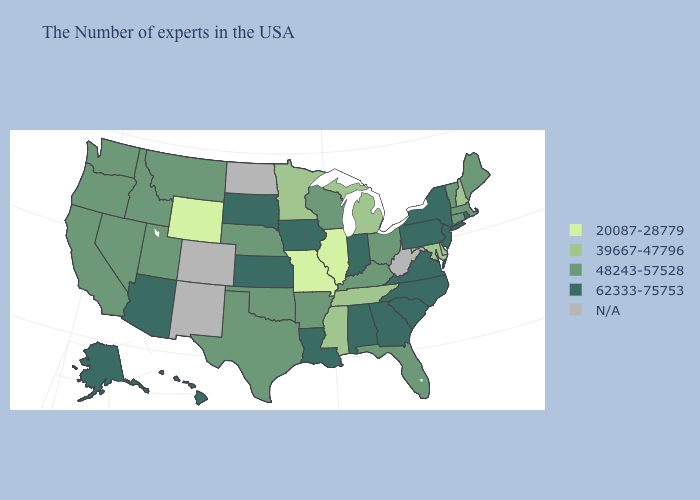Does Alabama have the highest value in the South?
Answer briefly. Yes. Which states have the lowest value in the USA?
Keep it brief. Illinois, Missouri, Wyoming. What is the lowest value in the Northeast?
Be succinct. 39667-47796. What is the highest value in the West ?
Keep it brief. 62333-75753. What is the value of North Carolina?
Answer briefly. 62333-75753. What is the highest value in the USA?
Quick response, please. 62333-75753. Does Rhode Island have the highest value in the Northeast?
Quick response, please. Yes. What is the value of Arkansas?
Write a very short answer. 48243-57528. What is the highest value in the USA?
Write a very short answer. 62333-75753. What is the value of Texas?
Answer briefly. 48243-57528. What is the value of Nebraska?
Be succinct. 48243-57528. Among the states that border Tennessee , which have the lowest value?
Concise answer only. Missouri. Among the states that border Kentucky , does Virginia have the lowest value?
Be succinct. No. Name the states that have a value in the range 20087-28779?
Short answer required. Illinois, Missouri, Wyoming. Name the states that have a value in the range 48243-57528?
Give a very brief answer. Maine, Massachusetts, Vermont, Connecticut, Ohio, Florida, Kentucky, Wisconsin, Arkansas, Nebraska, Oklahoma, Texas, Utah, Montana, Idaho, Nevada, California, Washington, Oregon. 